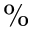<formula> <loc_0><loc_0><loc_500><loc_500>\%</formula> 